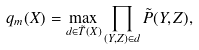Convert formula to latex. <formula><loc_0><loc_0><loc_500><loc_500>q _ { m } ( X ) = \max _ { d \in \tilde { T } ( X ) } \prod _ { ( Y , Z ) \in d } \tilde { P } ( Y , Z ) ,</formula> 